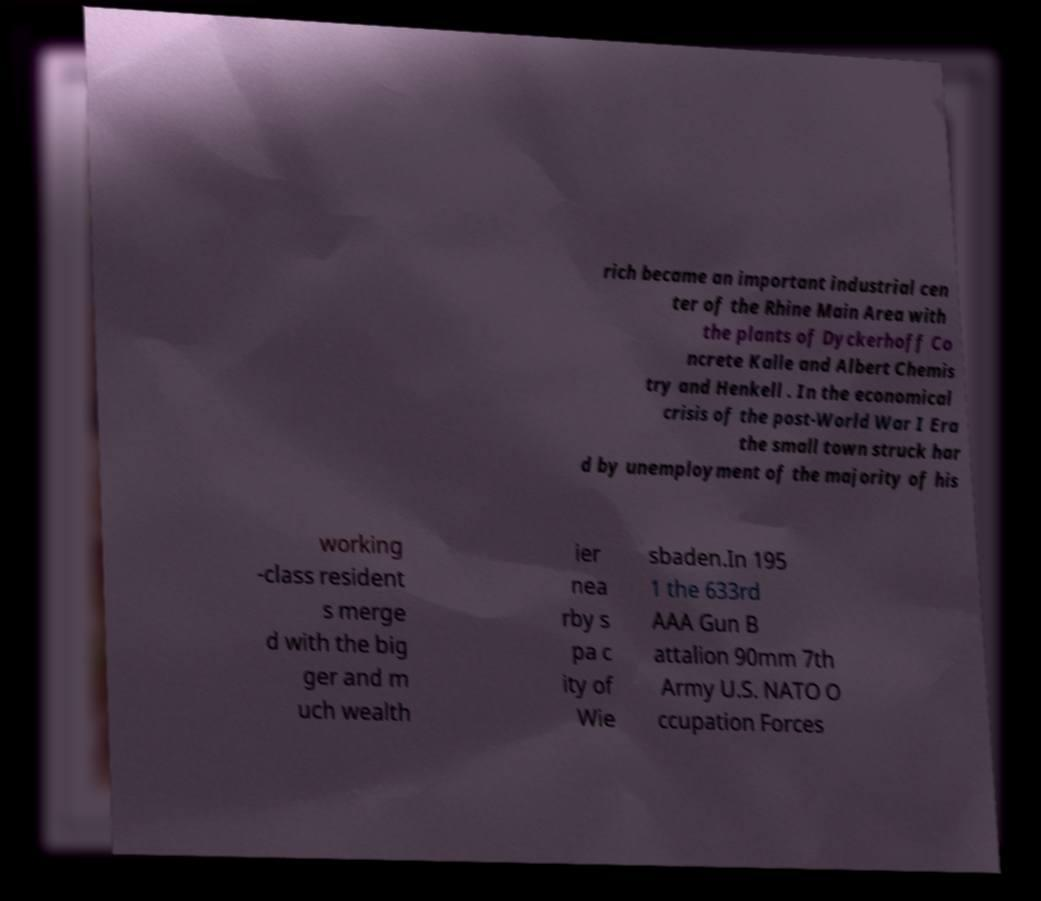For documentation purposes, I need the text within this image transcribed. Could you provide that? rich became an important industrial cen ter of the Rhine Main Area with the plants of Dyckerhoff Co ncrete Kalle and Albert Chemis try and Henkell . In the economical crisis of the post-World War I Era the small town struck har d by unemployment of the majority of his working -class resident s merge d with the big ger and m uch wealth ier nea rby s pa c ity of Wie sbaden.In 195 1 the 633rd AAA Gun B attalion 90mm 7th Army U.S. NATO O ccupation Forces 